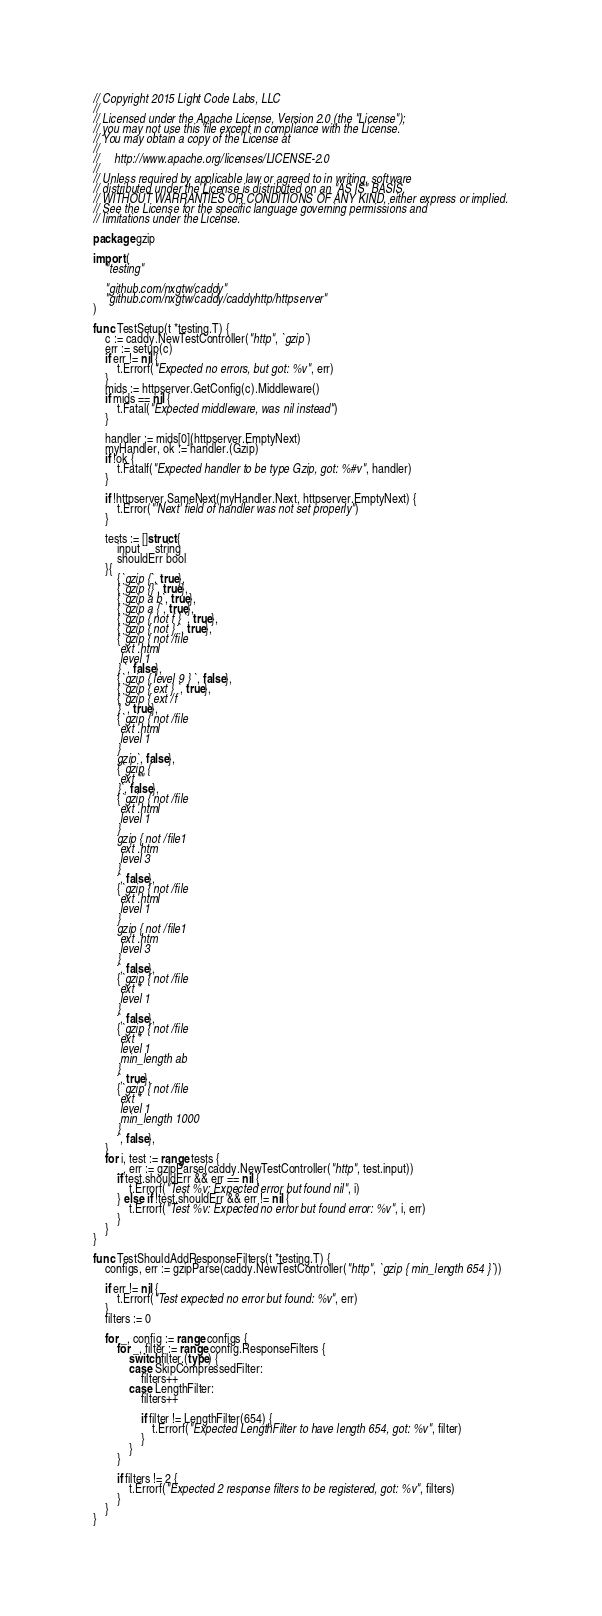<code> <loc_0><loc_0><loc_500><loc_500><_Go_>// Copyright 2015 Light Code Labs, LLC
//
// Licensed under the Apache License, Version 2.0 (the "License");
// you may not use this file except in compliance with the License.
// You may obtain a copy of the License at
//
//     http://www.apache.org/licenses/LICENSE-2.0
//
// Unless required by applicable law or agreed to in writing, software
// distributed under the License is distributed on an "AS IS" BASIS,
// WITHOUT WARRANTIES OR CONDITIONS OF ANY KIND, either express or implied.
// See the License for the specific language governing permissions and
// limitations under the License.

package gzip

import (
	"testing"

	"github.com/nxgtw/caddy"
	"github.com/nxgtw/caddy/caddyhttp/httpserver"
)

func TestSetup(t *testing.T) {
	c := caddy.NewTestController("http", `gzip`)
	err := setup(c)
	if err != nil {
		t.Errorf("Expected no errors, but got: %v", err)
	}
	mids := httpserver.GetConfig(c).Middleware()
	if mids == nil {
		t.Fatal("Expected middleware, was nil instead")
	}

	handler := mids[0](httpserver.EmptyNext)
	myHandler, ok := handler.(Gzip)
	if !ok {
		t.Fatalf("Expected handler to be type Gzip, got: %#v", handler)
	}

	if !httpserver.SameNext(myHandler.Next, httpserver.EmptyNext) {
		t.Error("'Next' field of handler was not set properly")
	}

	tests := []struct {
		input     string
		shouldErr bool
	}{
		{`gzip {`, true},
		{`gzip {}`, true},
		{`gzip a b`, true},
		{`gzip a {`, true},
		{`gzip { not f } `, true},
		{`gzip { not } `, true},
		{`gzip { not /file
		 ext .html
		 level 1
		} `, false},
		{`gzip { level 9 } `, false},
		{`gzip { ext } `, true},
		{`gzip { ext /f
		} `, true},
		{`gzip { not /file
		 ext .html
		 level 1
		}
		gzip`, false},
		{`gzip {
		 ext ""
		}`, false},
		{`gzip { not /file
		 ext .html
		 level 1
		}
		gzip { not /file1
		 ext .htm
		 level 3
		}
		`, false},
		{`gzip { not /file
		 ext .html
		 level 1
		}
		gzip { not /file1
		 ext .htm
		 level 3
		}
		`, false},
		{`gzip { not /file
		 ext *
		 level 1
		}
		`, false},
		{`gzip { not /file
		 ext *
		 level 1
		 min_length ab
		}
		`, true},
		{`gzip { not /file
		 ext *
		 level 1
		 min_length 1000
		}
		`, false},
	}
	for i, test := range tests {
		_, err := gzipParse(caddy.NewTestController("http", test.input))
		if test.shouldErr && err == nil {
			t.Errorf("Test %v: Expected error but found nil", i)
		} else if !test.shouldErr && err != nil {
			t.Errorf("Test %v: Expected no error but found error: %v", i, err)
		}
	}
}

func TestShouldAddResponseFilters(t *testing.T) {
	configs, err := gzipParse(caddy.NewTestController("http", `gzip { min_length 654 }`))

	if err != nil {
		t.Errorf("Test expected no error but found: %v", err)
	}
	filters := 0

	for _, config := range configs {
		for _, filter := range config.ResponseFilters {
			switch filter.(type) {
			case SkipCompressedFilter:
				filters++
			case LengthFilter:
				filters++

				if filter != LengthFilter(654) {
					t.Errorf("Expected LengthFilter to have length 654, got: %v", filter)
				}
			}
		}

		if filters != 2 {
			t.Errorf("Expected 2 response filters to be registered, got: %v", filters)
		}
	}
}
</code> 